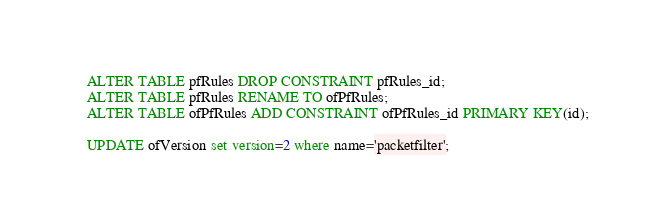Convert code to text. <code><loc_0><loc_0><loc_500><loc_500><_SQL_>ALTER TABLE pfRules DROP CONSTRAINT pfRules_id;
ALTER TABLE pfRules RENAME TO ofPfRules;
ALTER TABLE ofPfRules ADD CONSTRAINT ofPfRules_id PRIMARY KEY(id);

UPDATE ofVersion set version=2 where name='packetfilter';
</code> 